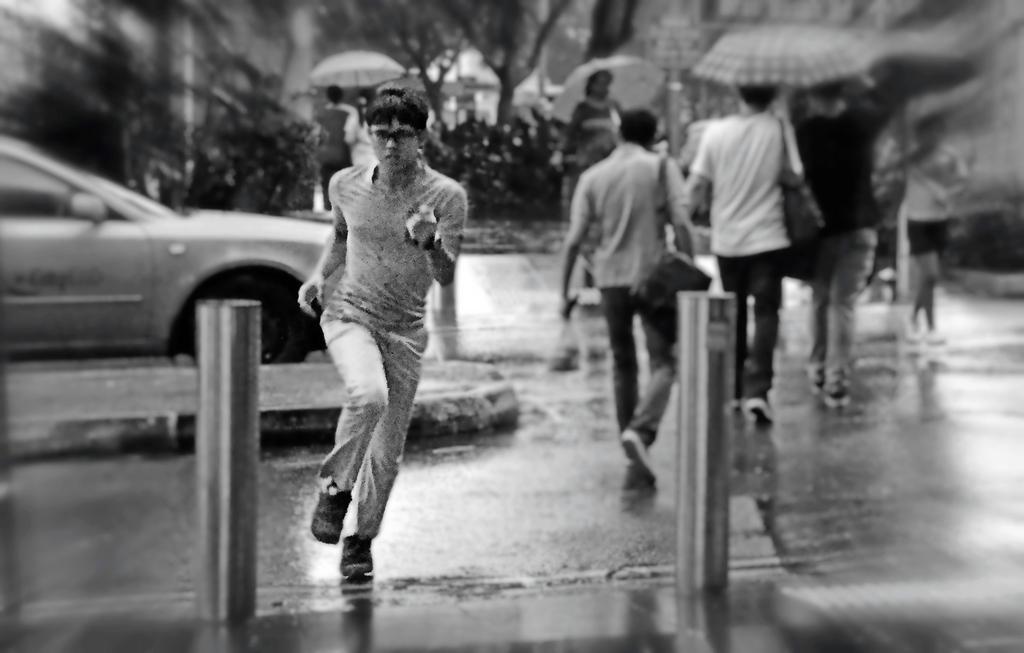Please provide a concise description of this image. This is an edited picture. in this picture we can see it is raining. In the foreground we can see a person running on the road and there are two poles. In the middle of the picture we can see people walking on the road carrying umbrellas. On the left we can see a car. In the background there are trees and people. 